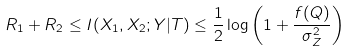<formula> <loc_0><loc_0><loc_500><loc_500>R _ { 1 } + R _ { 2 } \leq I ( X _ { 1 } , X _ { 2 } ; Y | T ) \leq \frac { 1 } { 2 } \log \left ( 1 + \frac { f ( Q ) } { \sigma _ { Z } ^ { 2 } } \right )</formula> 